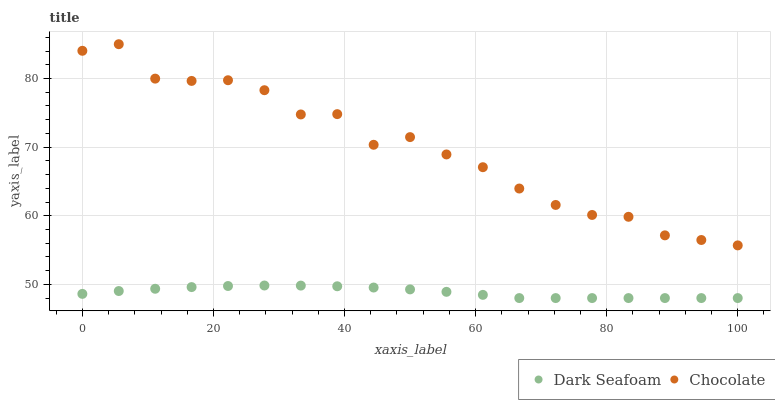Does Dark Seafoam have the minimum area under the curve?
Answer yes or no. Yes. Does Chocolate have the maximum area under the curve?
Answer yes or no. Yes. Does Chocolate have the minimum area under the curve?
Answer yes or no. No. Is Dark Seafoam the smoothest?
Answer yes or no. Yes. Is Chocolate the roughest?
Answer yes or no. Yes. Is Chocolate the smoothest?
Answer yes or no. No. Does Dark Seafoam have the lowest value?
Answer yes or no. Yes. Does Chocolate have the lowest value?
Answer yes or no. No. Does Chocolate have the highest value?
Answer yes or no. Yes. Is Dark Seafoam less than Chocolate?
Answer yes or no. Yes. Is Chocolate greater than Dark Seafoam?
Answer yes or no. Yes. Does Dark Seafoam intersect Chocolate?
Answer yes or no. No. 